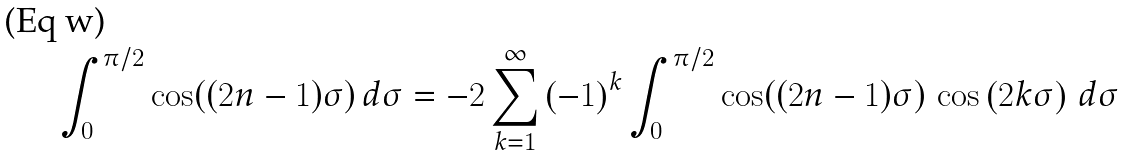<formula> <loc_0><loc_0><loc_500><loc_500>\int _ { 0 } ^ { \pi / 2 } \cos ( ( 2 n - 1 ) \sigma ) \, d \sigma = - 2 \sum _ { k = 1 } ^ { \infty } \left ( - 1 \right ) ^ { k } \int _ { 0 } ^ { \pi / 2 } \cos ( ( 2 n - 1 ) \sigma ) \, \cos \left ( 2 k \sigma \right ) \, d \sigma</formula> 